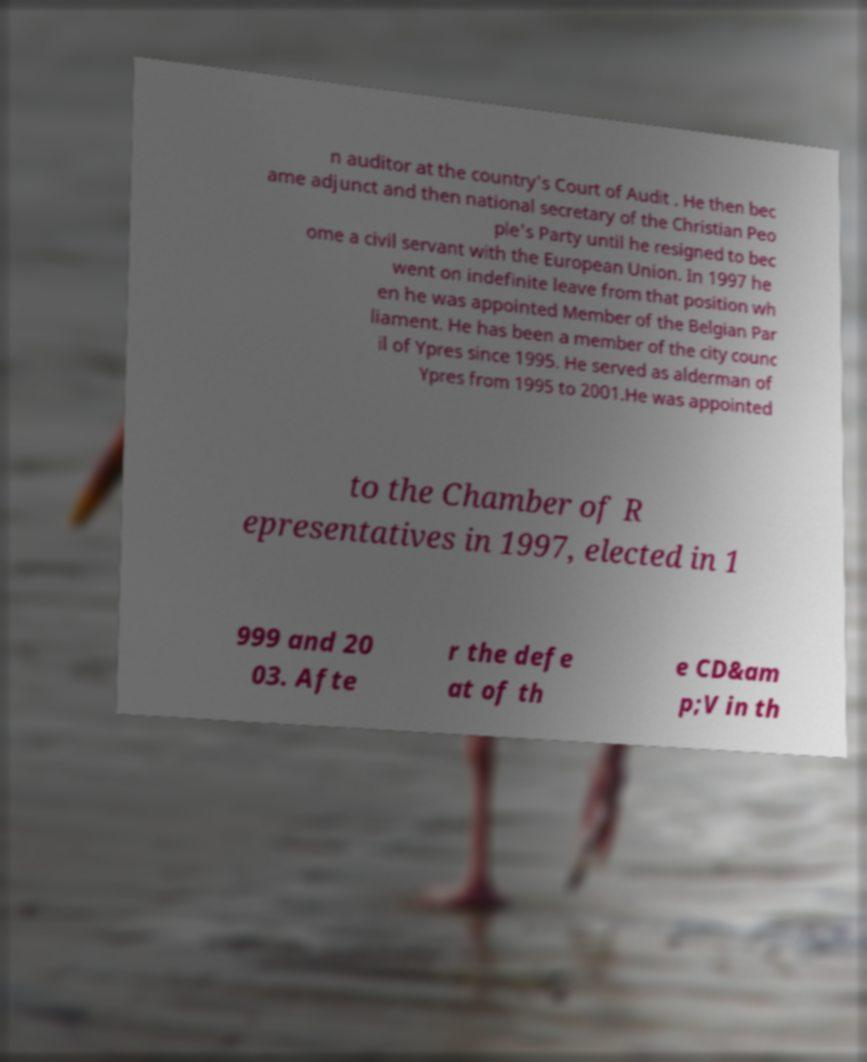Could you extract and type out the text from this image? n auditor at the country's Court of Audit . He then bec ame adjunct and then national secretary of the Christian Peo ple's Party until he resigned to bec ome a civil servant with the European Union. In 1997 he went on indefinite leave from that position wh en he was appointed Member of the Belgian Par liament. He has been a member of the city counc il of Ypres since 1995. He served as alderman of Ypres from 1995 to 2001.He was appointed to the Chamber of R epresentatives in 1997, elected in 1 999 and 20 03. Afte r the defe at of th e CD&am p;V in th 